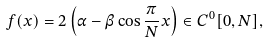Convert formula to latex. <formula><loc_0><loc_0><loc_500><loc_500>f ( x ) = 2 \left ( \alpha - \beta \cos \frac { \pi } { N } x \right ) \in C ^ { 0 } [ 0 , N ] ,</formula> 